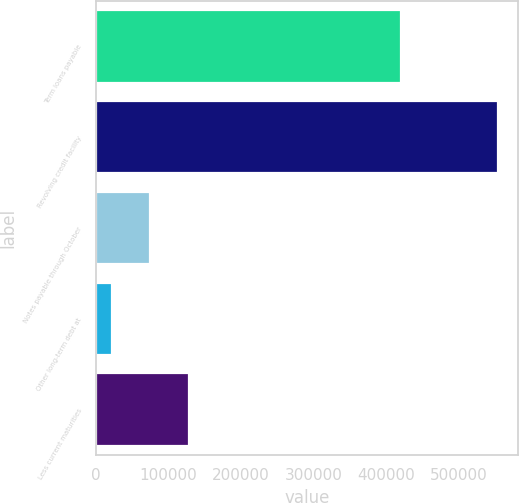Convert chart to OTSL. <chart><loc_0><loc_0><loc_500><loc_500><bar_chart><fcel>Term loans payable<fcel>Revolving credit facility<fcel>Notes payable through October<fcel>Other long-term debt at<fcel>Less current maturities<nl><fcel>420625<fcel>553964<fcel>74738.3<fcel>21491<fcel>127986<nl></chart> 